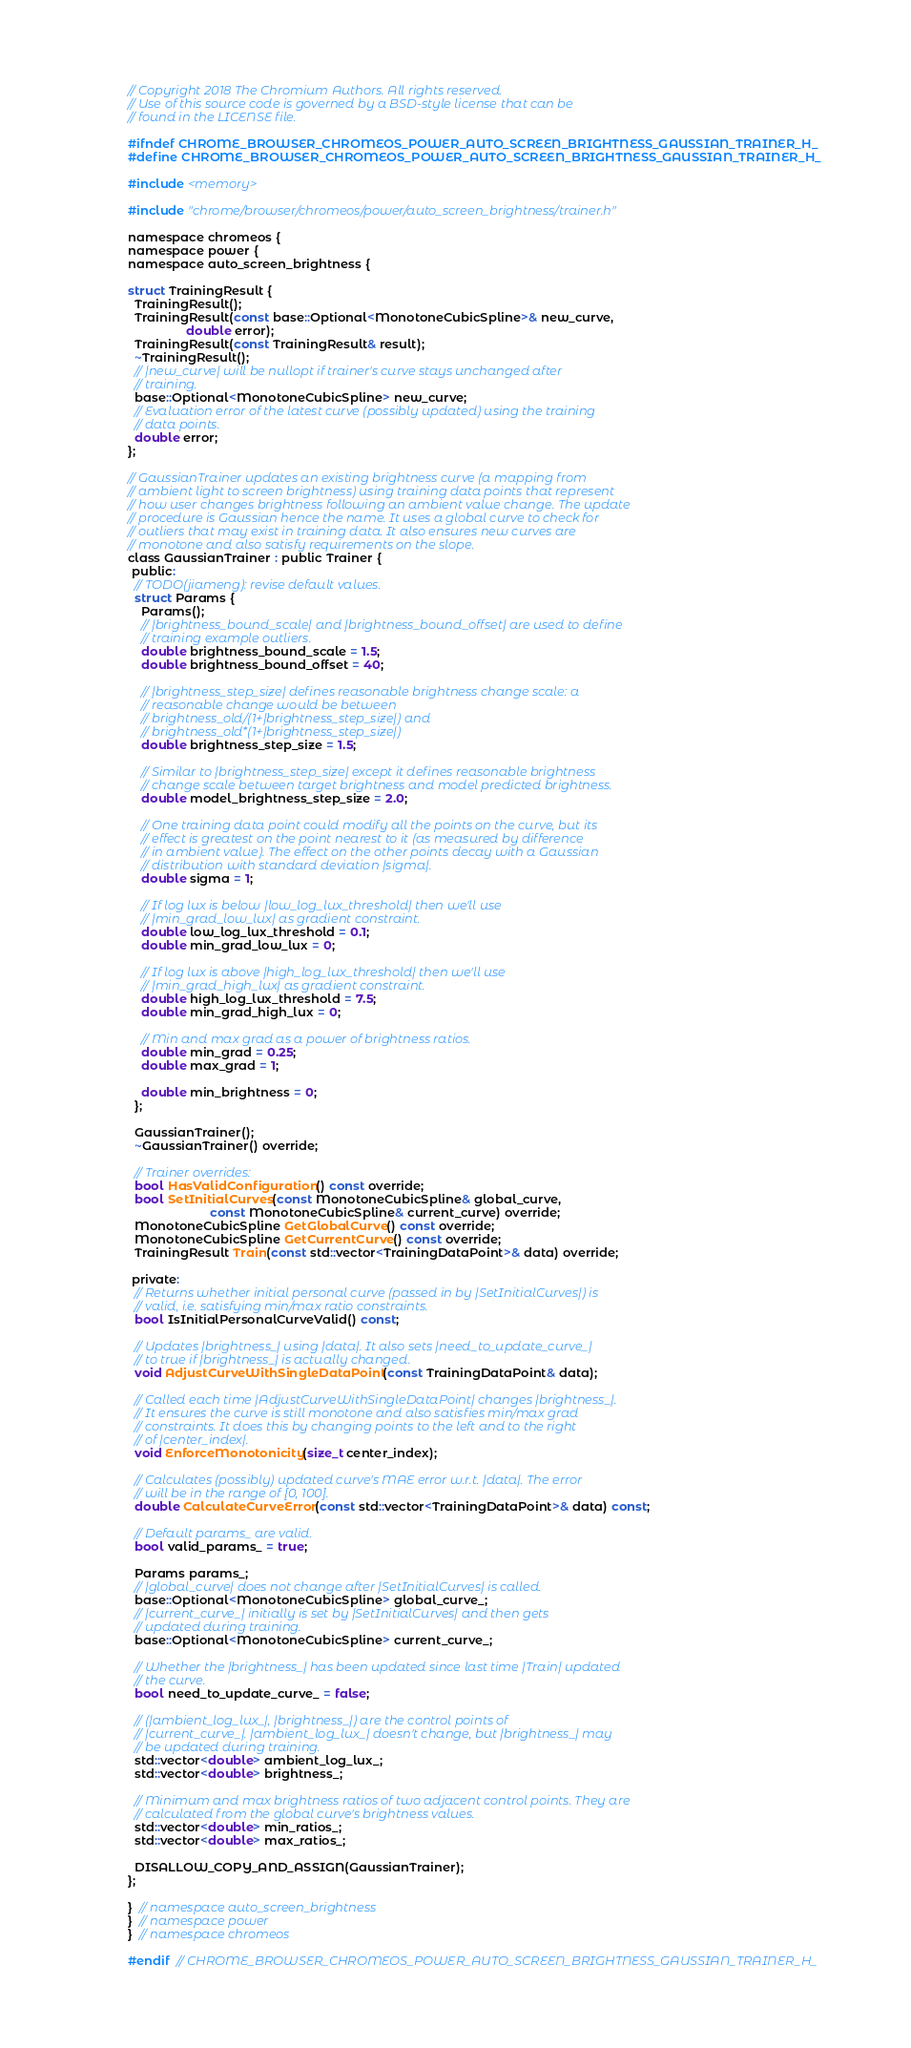<code> <loc_0><loc_0><loc_500><loc_500><_C_>// Copyright 2018 The Chromium Authors. All rights reserved.
// Use of this source code is governed by a BSD-style license that can be
// found in the LICENSE file.

#ifndef CHROME_BROWSER_CHROMEOS_POWER_AUTO_SCREEN_BRIGHTNESS_GAUSSIAN_TRAINER_H_
#define CHROME_BROWSER_CHROMEOS_POWER_AUTO_SCREEN_BRIGHTNESS_GAUSSIAN_TRAINER_H_

#include <memory>

#include "chrome/browser/chromeos/power/auto_screen_brightness/trainer.h"

namespace chromeos {
namespace power {
namespace auto_screen_brightness {

struct TrainingResult {
  TrainingResult();
  TrainingResult(const base::Optional<MonotoneCubicSpline>& new_curve,
                 double error);
  TrainingResult(const TrainingResult& result);
  ~TrainingResult();
  // |new_curve| will be nullopt if trainer's curve stays unchanged after
  // training.
  base::Optional<MonotoneCubicSpline> new_curve;
  // Evaluation error of the latest curve (possibly updated) using the training
  // data points.
  double error;
};

// GaussianTrainer updates an existing brightness curve (a mapping from
// ambient light to screen brightness) using training data points that represent
// how user changes brightness following an ambient value change. The update
// procedure is Gaussian hence the name. It uses a global curve to check for
// outliers that may exist in training data. It also ensures new curves are
// monotone and also satisfy requirements on the slope.
class GaussianTrainer : public Trainer {
 public:
  // TODO(jiameng): revise default values.
  struct Params {
    Params();
    // |brightness_bound_scale| and |brightness_bound_offset| are used to define
    // training example outliers.
    double brightness_bound_scale = 1.5;
    double brightness_bound_offset = 40;

    // |brightness_step_size| defines reasonable brightness change scale: a
    // reasonable change would be between
    // brightness_old/(1+|brightness_step_size|) and
    // brightness_old*(1+|brightness_step_size|)
    double brightness_step_size = 1.5;

    // Similar to |brightness_step_size| except it defines reasonable brightness
    // change scale between target brightness and model predicted brightness.
    double model_brightness_step_size = 2.0;

    // One training data point could modify all the points on the curve, but its
    // effect is greatest on the point nearest to it (as measured by difference
    // in ambient value). The effect on the other points decay with a Gaussian
    // distribution with standard deviation |sigma|.
    double sigma = 1;

    // If log lux is below |low_log_lux_threshold| then we'll use
    // |min_grad_low_lux| as gradient constraint.
    double low_log_lux_threshold = 0.1;
    double min_grad_low_lux = 0;

    // If log lux is above |high_log_lux_threshold| then we'll use
    // |min_grad_high_lux| as gradient constraint.
    double high_log_lux_threshold = 7.5;
    double min_grad_high_lux = 0;

    // Min and max grad as a power of brightness ratios.
    double min_grad = 0.25;
    double max_grad = 1;

    double min_brightness = 0;
  };

  GaussianTrainer();
  ~GaussianTrainer() override;

  // Trainer overrides:
  bool HasValidConfiguration() const override;
  bool SetInitialCurves(const MonotoneCubicSpline& global_curve,
                        const MonotoneCubicSpline& current_curve) override;
  MonotoneCubicSpline GetGlobalCurve() const override;
  MonotoneCubicSpline GetCurrentCurve() const override;
  TrainingResult Train(const std::vector<TrainingDataPoint>& data) override;

 private:
  // Returns whether initial personal curve (passed in by |SetInitialCurves|) is
  // valid, i.e. satisfying min/max ratio constraints.
  bool IsInitialPersonalCurveValid() const;

  // Updates |brightness_| using |data|. It also sets |need_to_update_curve_|
  // to true if |brightness_| is actually changed.
  void AdjustCurveWithSingleDataPoint(const TrainingDataPoint& data);

  // Called each time |AdjustCurveWithSingleDataPoint| changes |brightness_|.
  // It ensures the curve is still monotone and also satisfies min/max grad
  // constraints. It does this by changing points to the left and to the right
  // of |center_index|.
  void EnforceMonotonicity(size_t center_index);

  // Calculates (possibly) updated curve's MAE error w.r.t. |data|. The error
  // will be in the range of [0, 100].
  double CalculateCurveError(const std::vector<TrainingDataPoint>& data) const;

  // Default params_ are valid.
  bool valid_params_ = true;

  Params params_;
  // |global_curve| does not change after |SetInitialCurves| is called.
  base::Optional<MonotoneCubicSpline> global_curve_;
  // |current_curve_| initially is set by |SetInitialCurves| and then gets
  // updated during training.
  base::Optional<MonotoneCubicSpline> current_curve_;

  // Whether the |brightness_| has been updated since last time |Train| updated
  // the curve.
  bool need_to_update_curve_ = false;

  // (|ambient_log_lux_|, |brightness_|) are the control points of
  // |current_curve_|. |ambient_log_lux_| doesn't change, but |brightness_| may
  // be updated during training.
  std::vector<double> ambient_log_lux_;
  std::vector<double> brightness_;

  // Minimum and max brightness ratios of two adjacent control points. They are
  // calculated from the global curve's brightness values.
  std::vector<double> min_ratios_;
  std::vector<double> max_ratios_;

  DISALLOW_COPY_AND_ASSIGN(GaussianTrainer);
};

}  // namespace auto_screen_brightness
}  // namespace power
}  // namespace chromeos

#endif  // CHROME_BROWSER_CHROMEOS_POWER_AUTO_SCREEN_BRIGHTNESS_GAUSSIAN_TRAINER_H_
</code> 